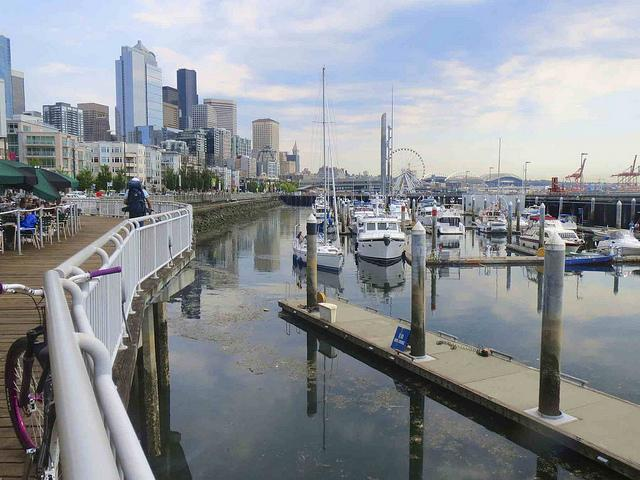What area is shown here?

Choices:
A) city highway
B) race track
C) bike path
D) harbor harbor 